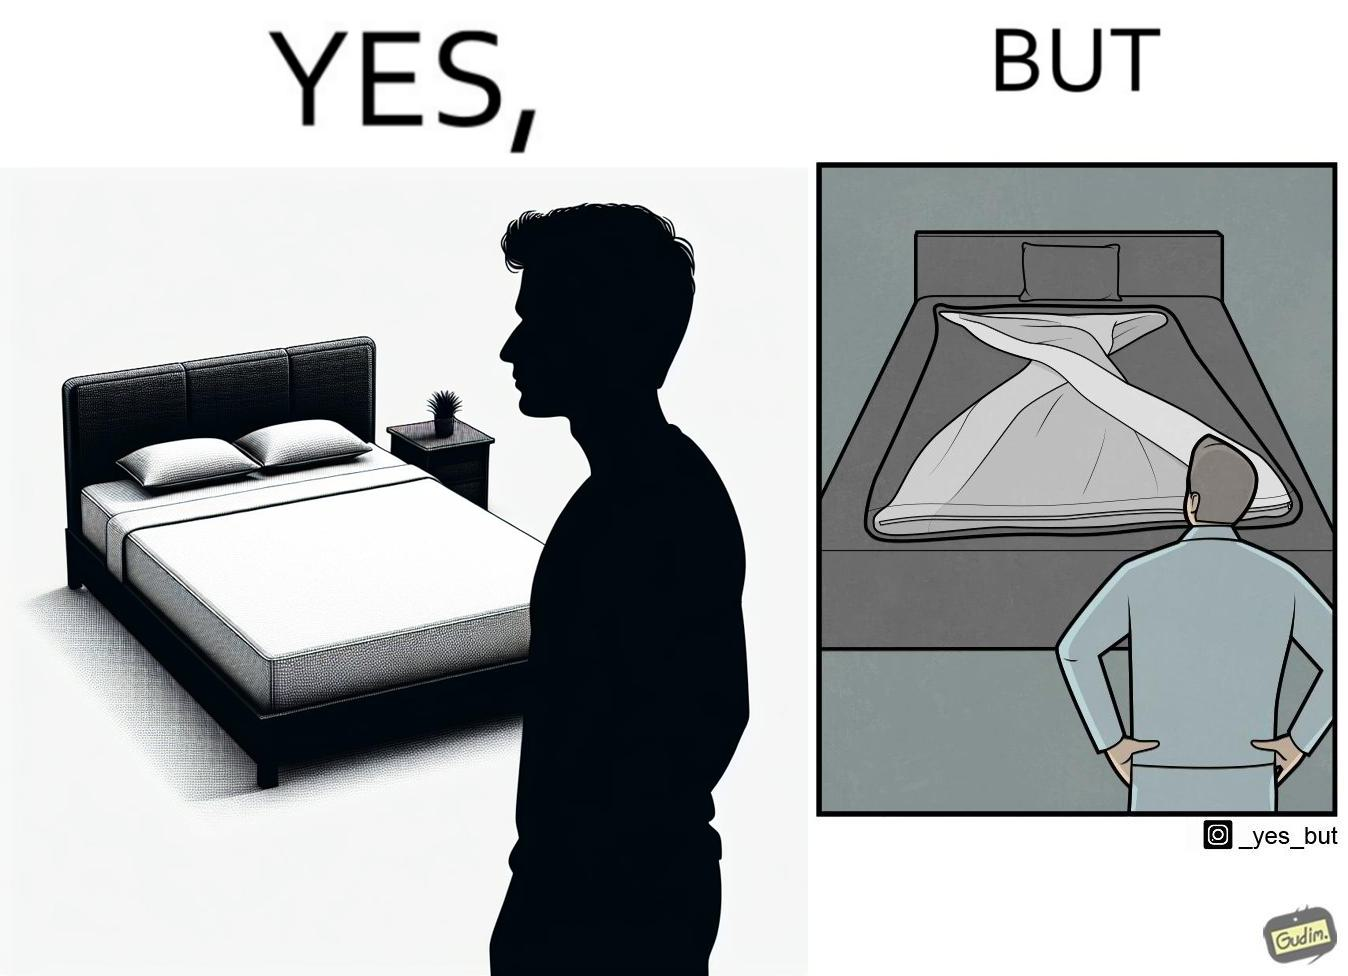Is this a satirical image? Yes, this image is satirical. 